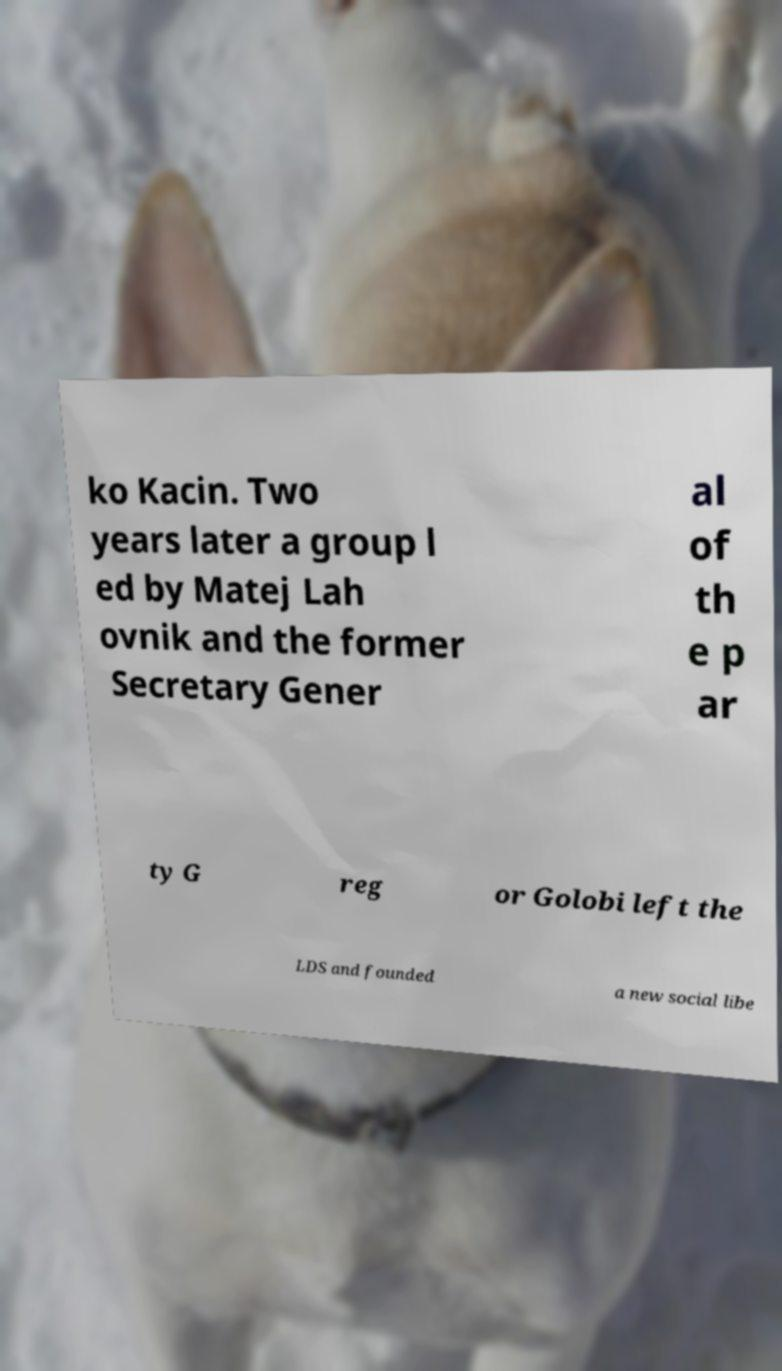Could you extract and type out the text from this image? ko Kacin. Two years later a group l ed by Matej Lah ovnik and the former Secretary Gener al of th e p ar ty G reg or Golobi left the LDS and founded a new social libe 